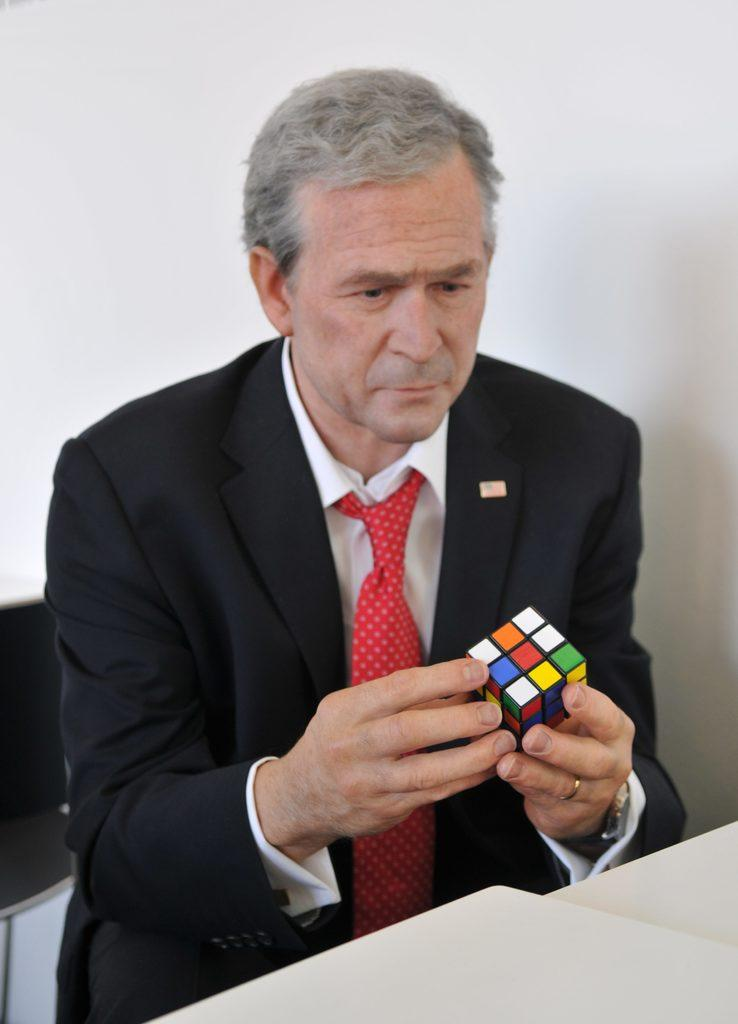What is the person in the image doing? The person is sitting and playing with a cube. What object is in front of the person? There is a table in front of the person. What is visible behind the person? There is a wall behind the person. What type of screw can be seen in the image? There is no screw present in the image. Is the person in the image guiding a boat on the water? There is no boat or water present in the image; the person is playing with a cube while sitting at a table. 